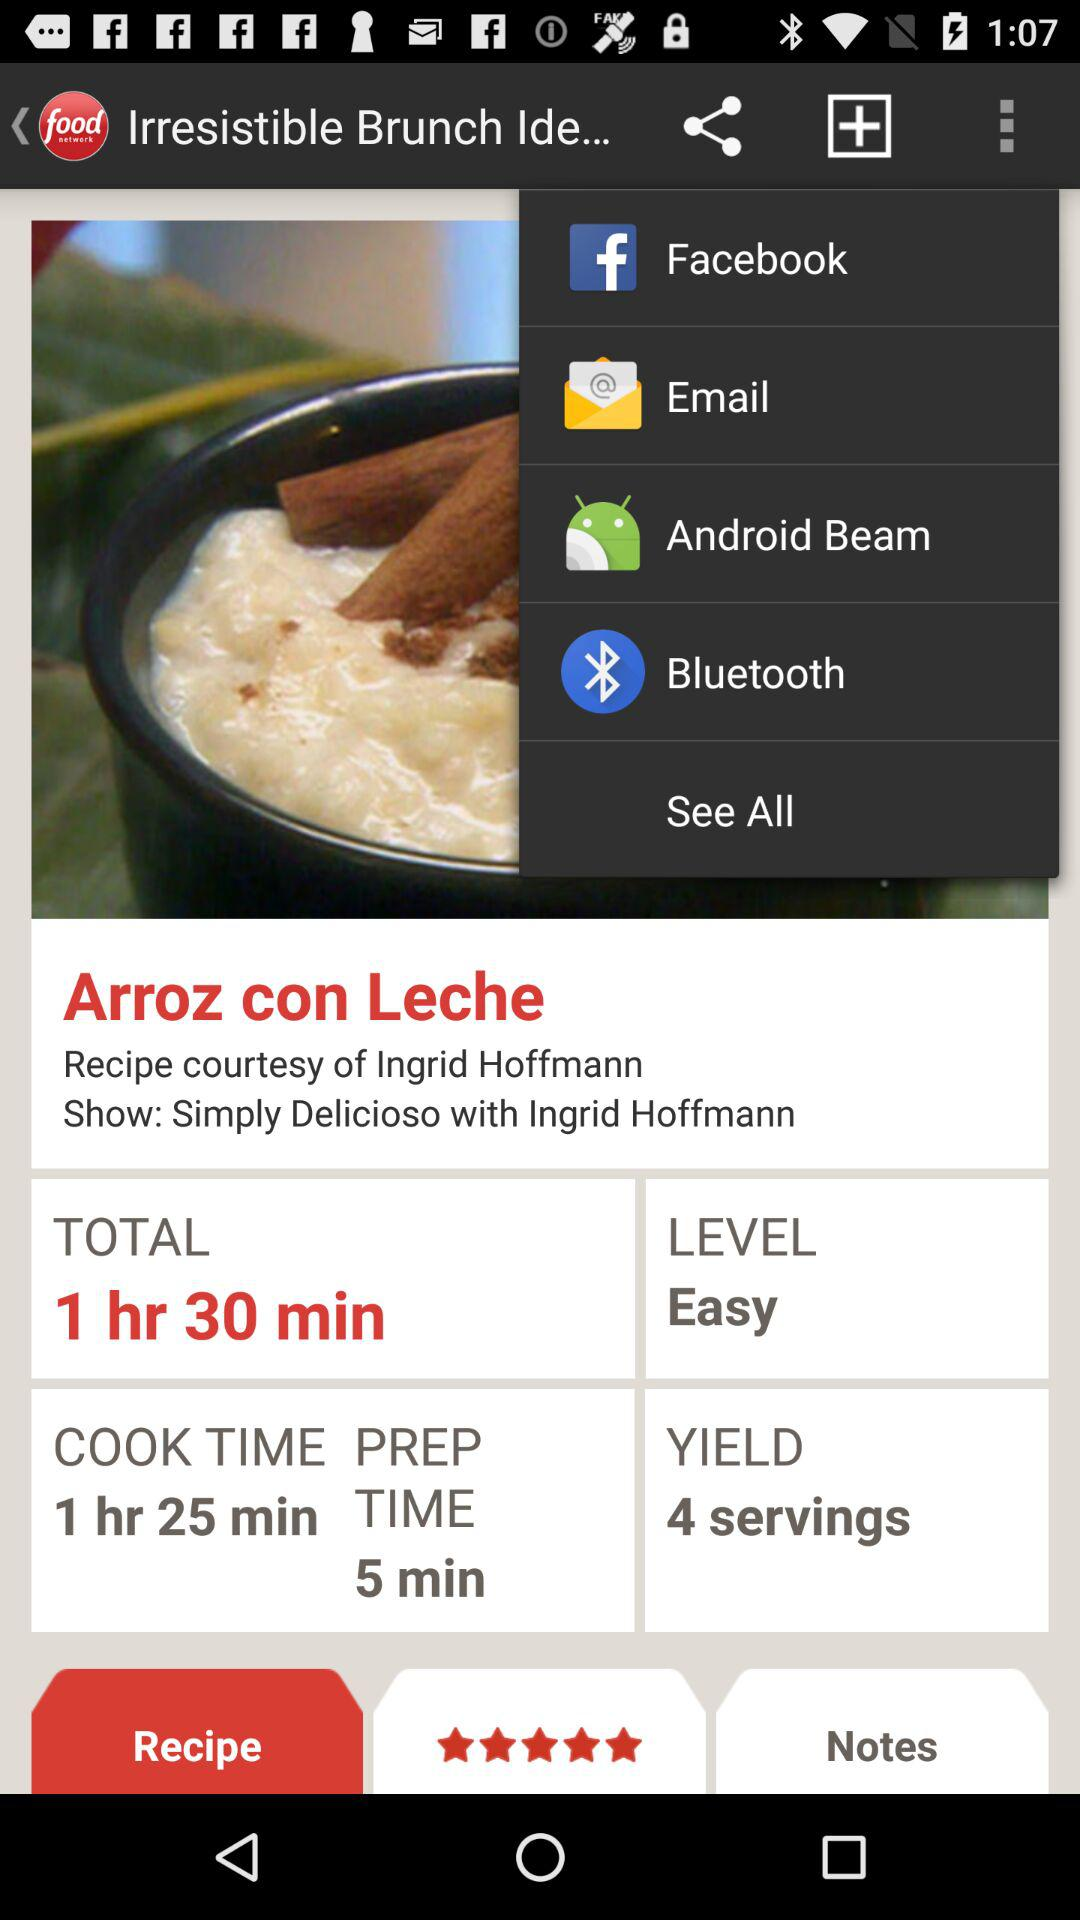What are the sharing options? The sharing options are "Facebook", "Email", "Android Beam" and "Bluetooth". 